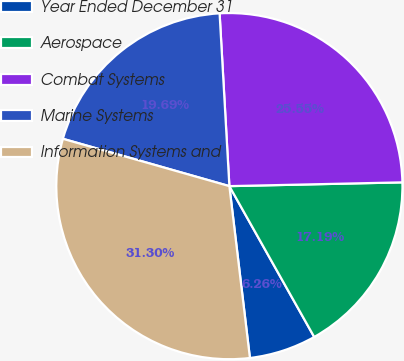Convert chart. <chart><loc_0><loc_0><loc_500><loc_500><pie_chart><fcel>Year Ended December 31<fcel>Aerospace<fcel>Combat Systems<fcel>Marine Systems<fcel>Information Systems and<nl><fcel>6.26%<fcel>17.19%<fcel>25.55%<fcel>19.69%<fcel>31.3%<nl></chart> 